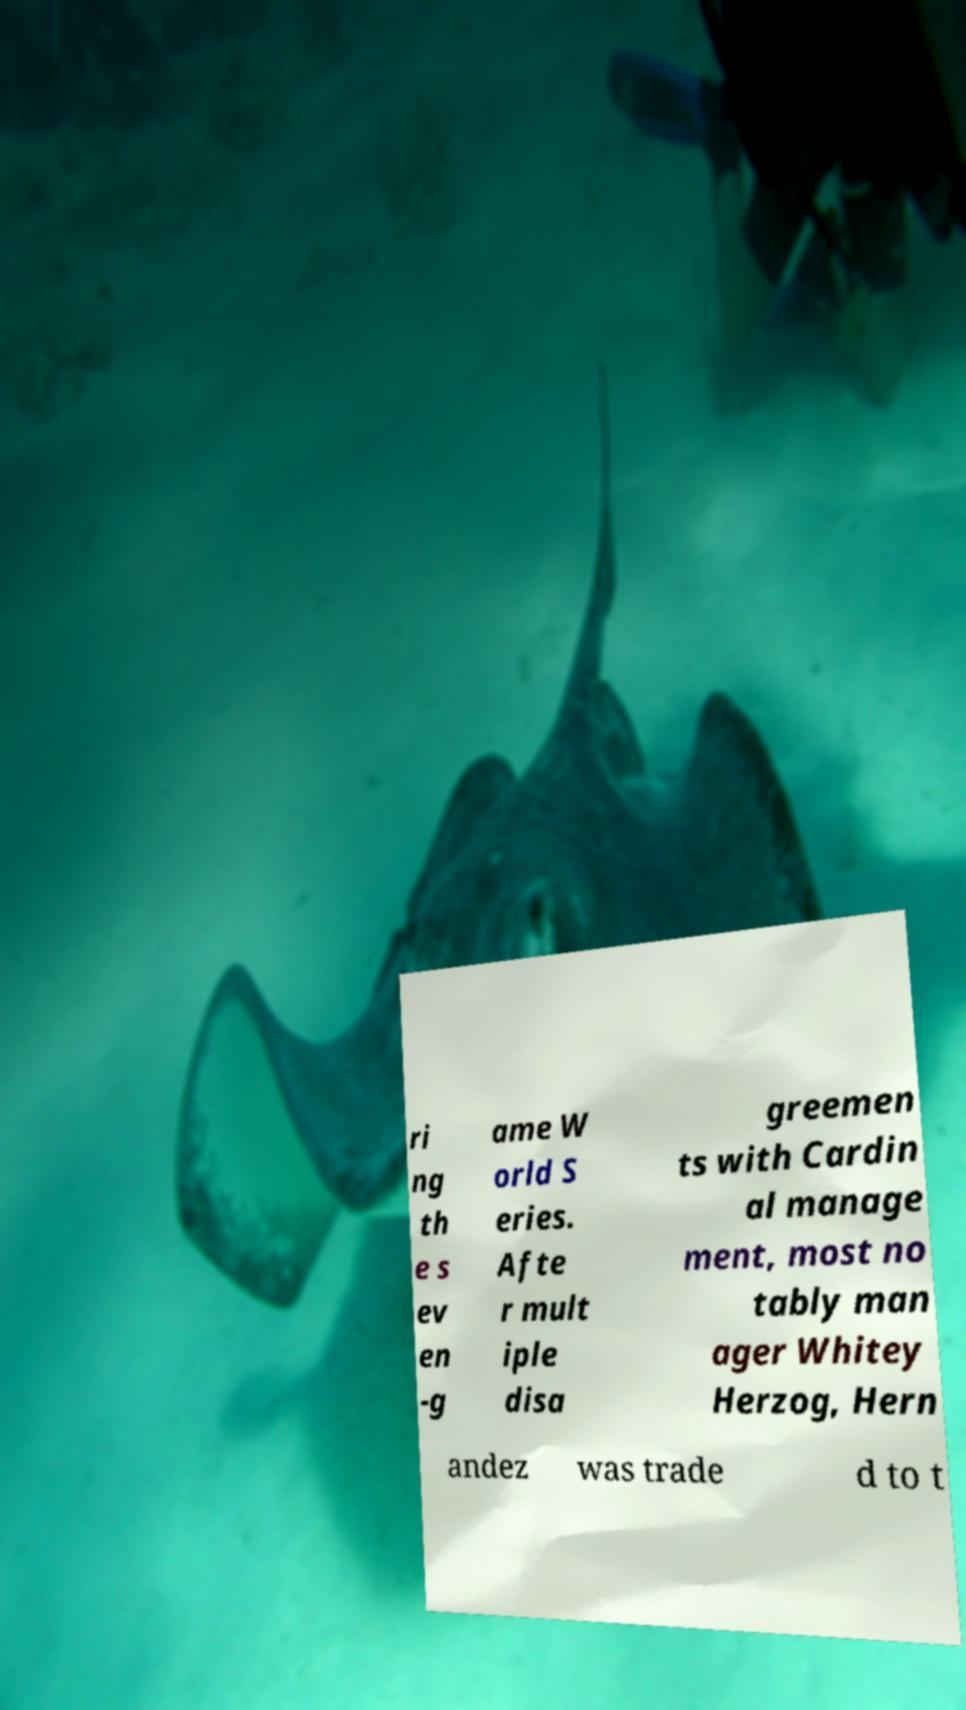For documentation purposes, I need the text within this image transcribed. Could you provide that? ri ng th e s ev en -g ame W orld S eries. Afte r mult iple disa greemen ts with Cardin al manage ment, most no tably man ager Whitey Herzog, Hern andez was trade d to t 